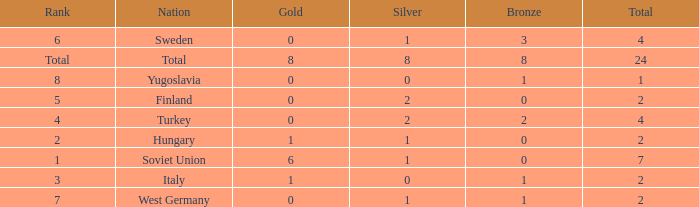What is the lowest Bronze, when Gold is less than 0? None. 